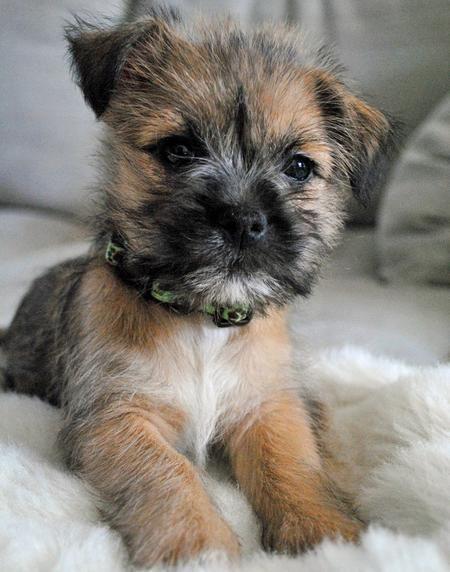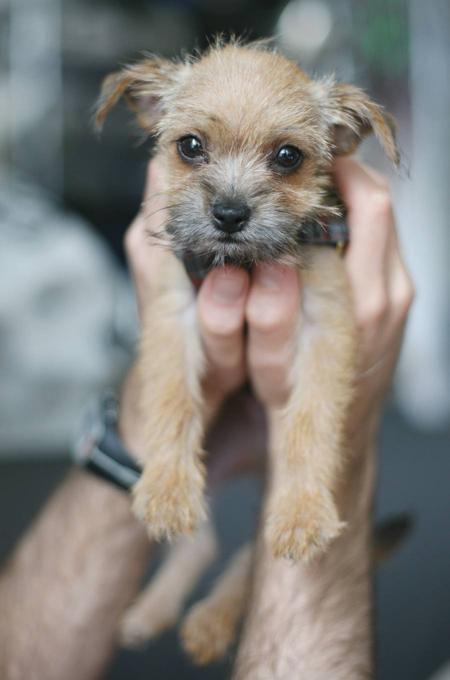The first image is the image on the left, the second image is the image on the right. Given the left and right images, does the statement "One dog is wearing a collar and has its mouth closed." hold true? Answer yes or no. Yes. The first image is the image on the left, the second image is the image on the right. For the images displayed, is the sentence "Left image shows a dog wearing a collar." factually correct? Answer yes or no. Yes. 